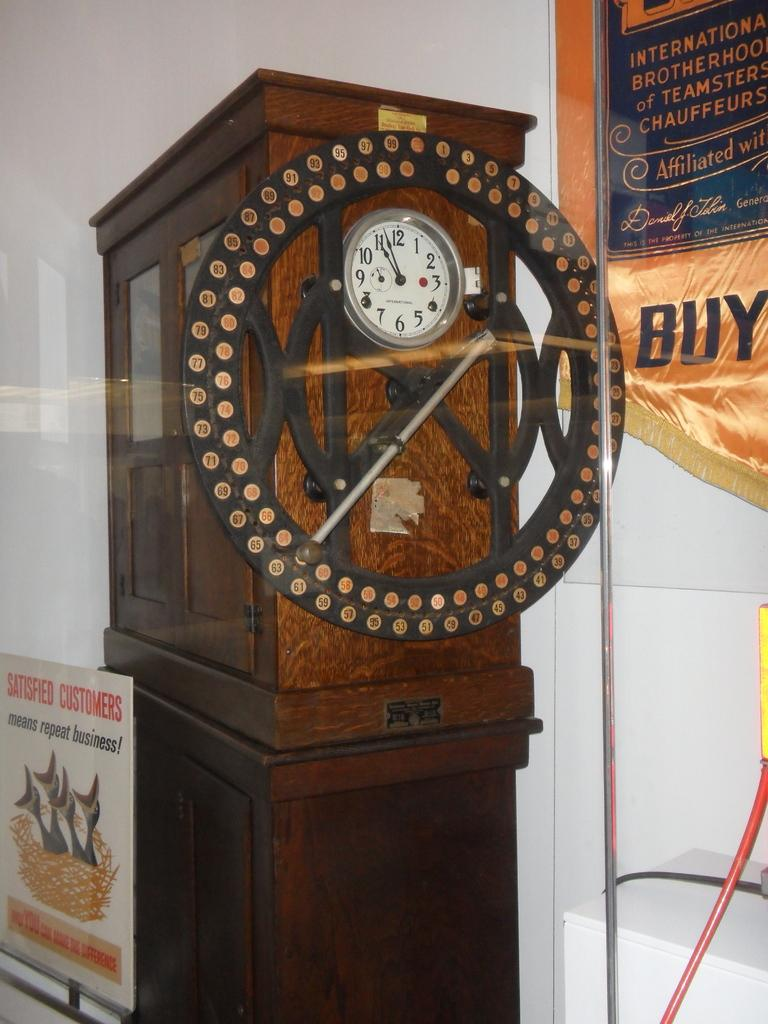<image>
Offer a succinct explanation of the picture presented. An unusual wooden clock on a wood pedestal displays a time of 11:55. 